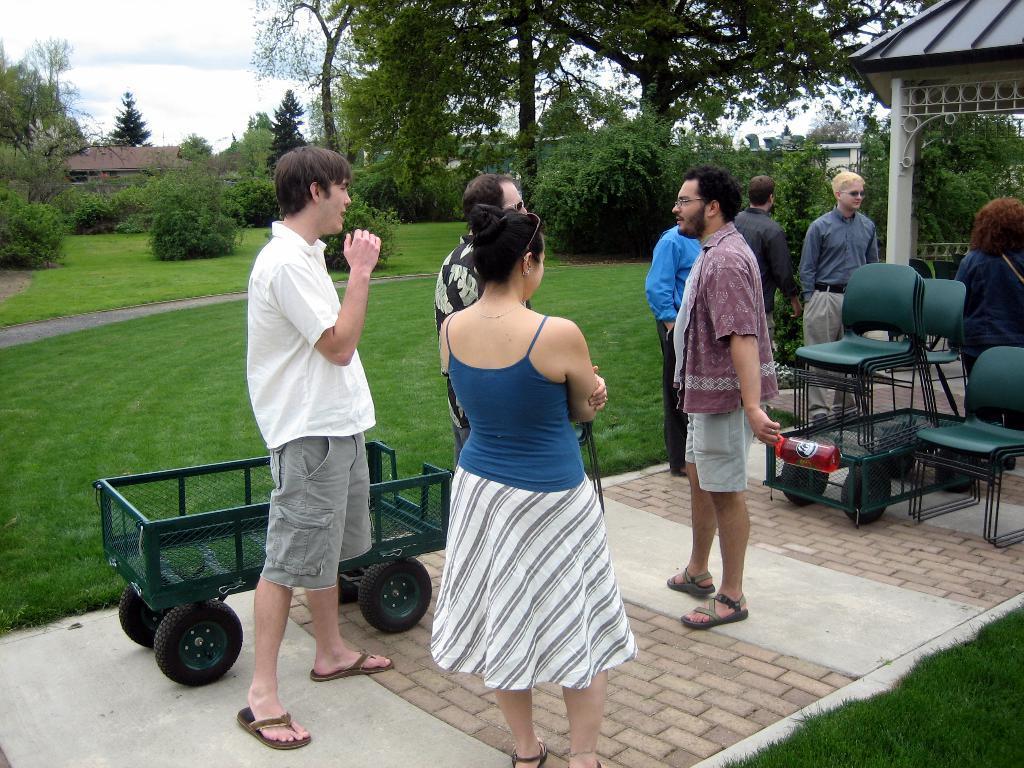Could you give a brief overview of what you see in this image? In this picture, we see people are standing. Beside them, we see a trolley vehicle. The man in the middle of the picture is holding a red color water bottle in his hand. Behind him, we see the chairs. On the right side, we see a gazebo. There are trees and buildings in the background. 